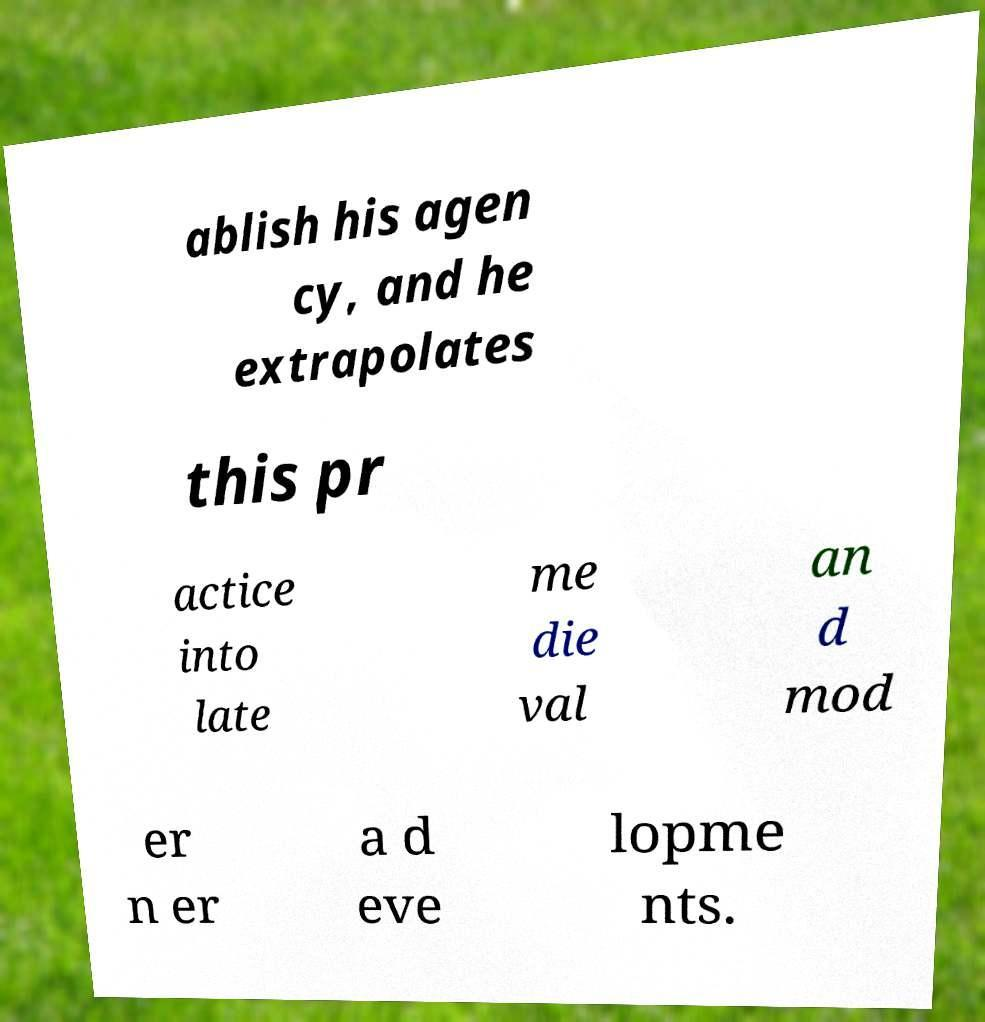Please identify and transcribe the text found in this image. ablish his agen cy, and he extrapolates this pr actice into late me die val an d mod er n er a d eve lopme nts. 